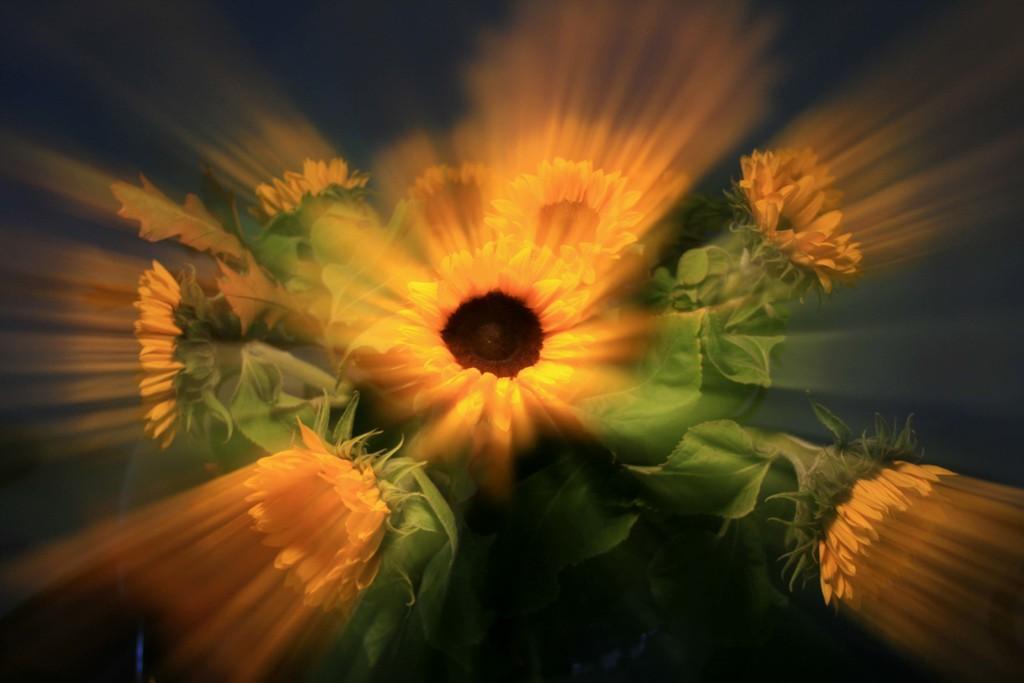Could you give a brief overview of what you see in this image? This image looks like it is edited. In this image there are flowers in yellow color along with the leaves. 